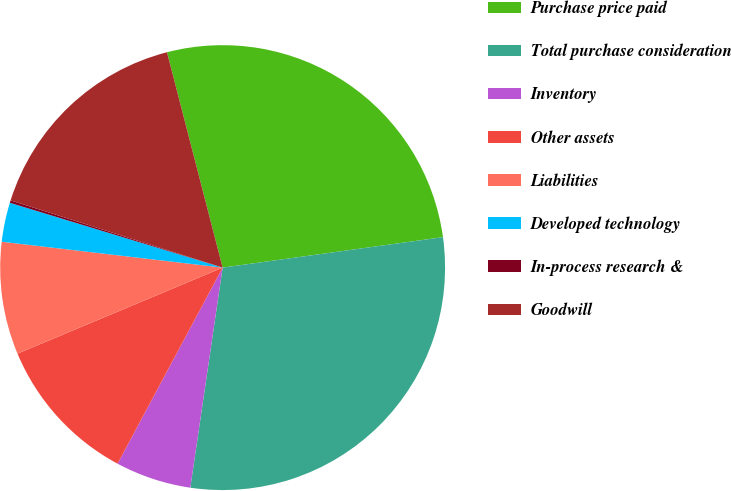Convert chart. <chart><loc_0><loc_0><loc_500><loc_500><pie_chart><fcel>Purchase price paid<fcel>Total purchase consideration<fcel>Inventory<fcel>Other assets<fcel>Liabilities<fcel>Developed technology<fcel>In-process research &<fcel>Goodwill<nl><fcel>26.84%<fcel>29.51%<fcel>5.51%<fcel>10.85%<fcel>8.18%<fcel>2.85%<fcel>0.18%<fcel>16.09%<nl></chart> 